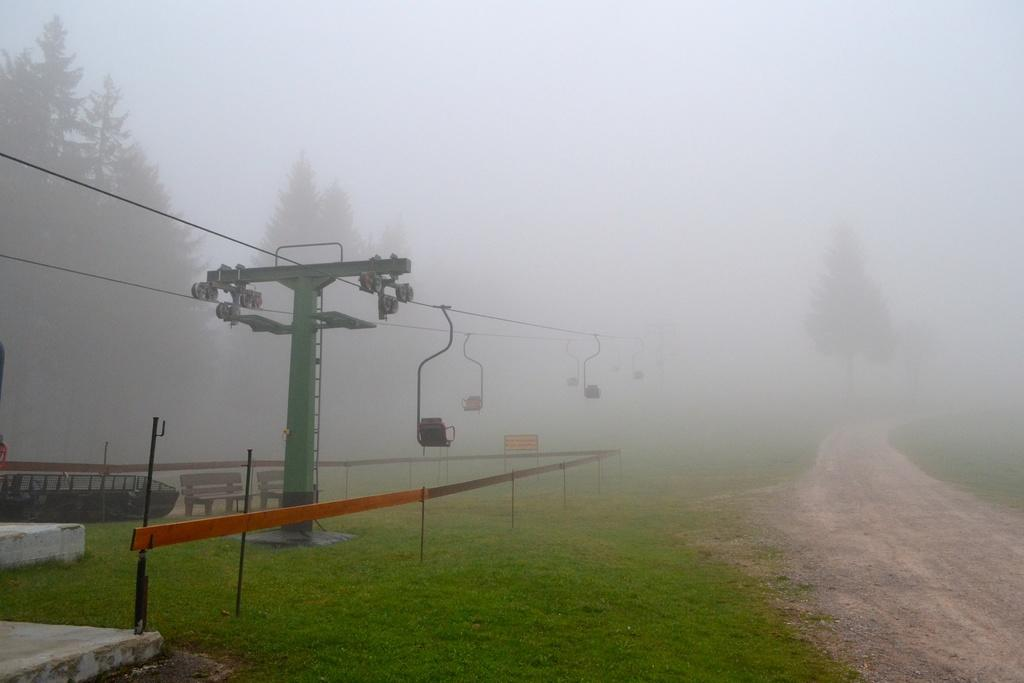What is one of the main structures in the image? There is a pole in the image. What else can be seen in the image related to electrical infrastructure? There are wires and cables in the image. What type of seating is available in the image? There is a chair and benches in the image. What type of natural environment is visible in the image? There are trees and grassy land in the image. What type of barrier is present in the image? There is fencing in the image. What type of pathway is visible in the image? There is a road in the image. What type of lace is draped over the pole in the image? There is no lace present in the image; only the pole, wires, cables, chair, trees, grassy land, fencing, benches, and road are visible. What part of the tramp's body can be seen interacting with the chair in the image? There is no tramp present in the image, so no body parts can be seen interacting with the chair. 